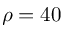Convert formula to latex. <formula><loc_0><loc_0><loc_500><loc_500>\rho = 4 0</formula> 